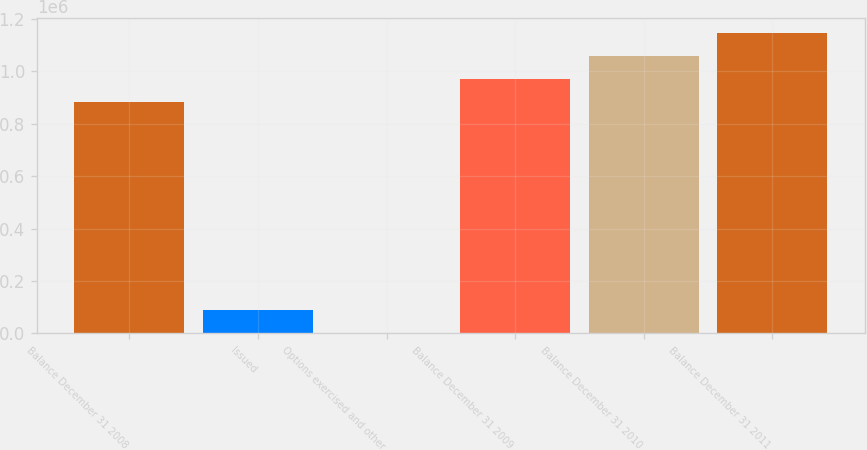Convert chart to OTSL. <chart><loc_0><loc_0><loc_500><loc_500><bar_chart><fcel>Balance December 31 2008<fcel>Issued<fcel>Options exercised and other<fcel>Balance December 31 2009<fcel>Balance December 31 2010<fcel>Balance December 31 2011<nl><fcel>881423<fcel>89151.6<fcel>523<fcel>970052<fcel>1.05868e+06<fcel>1.14731e+06<nl></chart> 